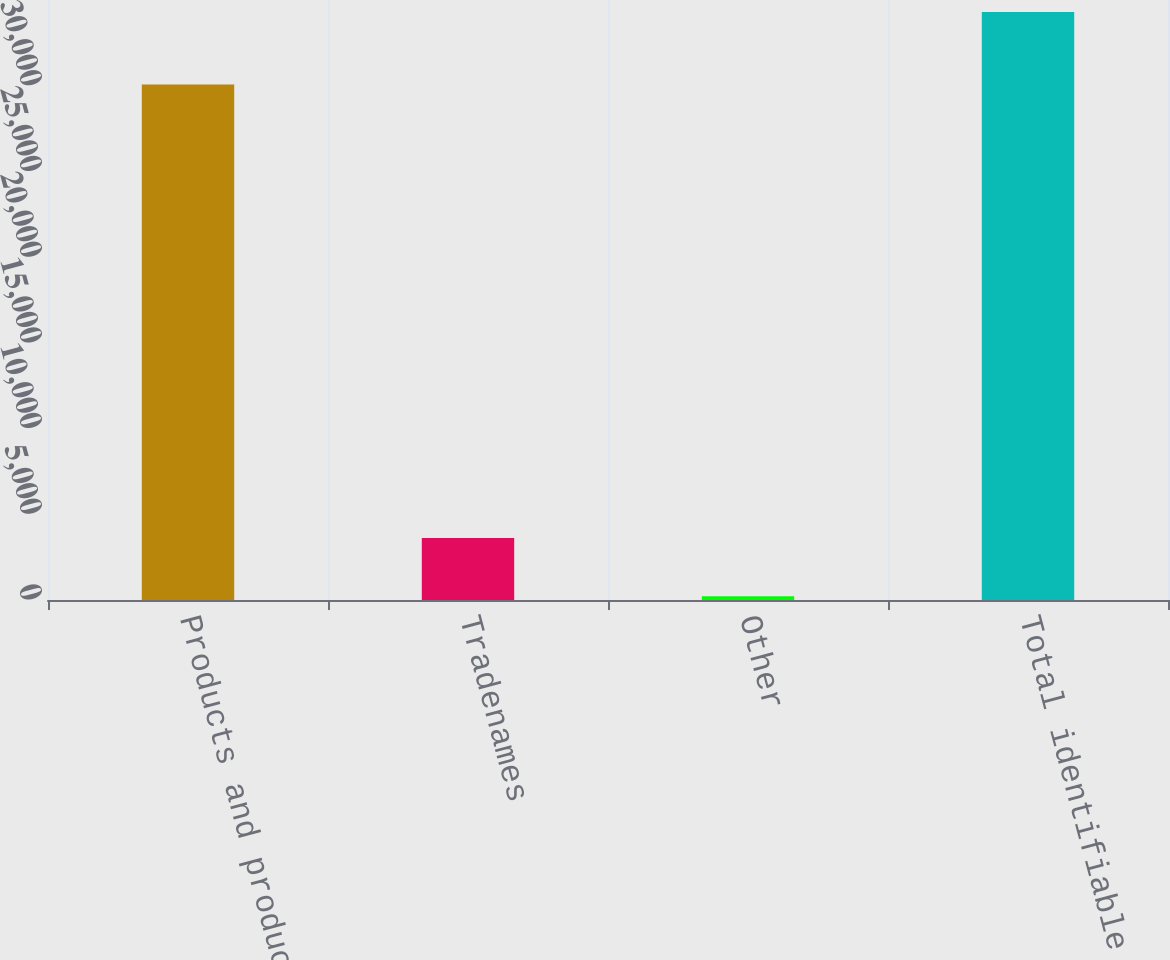<chart> <loc_0><loc_0><loc_500><loc_500><bar_chart><fcel>Products and product rights<fcel>Tradenames<fcel>Other<fcel>Total identifiable intangible<nl><fcel>30065<fcel>3621.9<fcel>213<fcel>34302<nl></chart> 